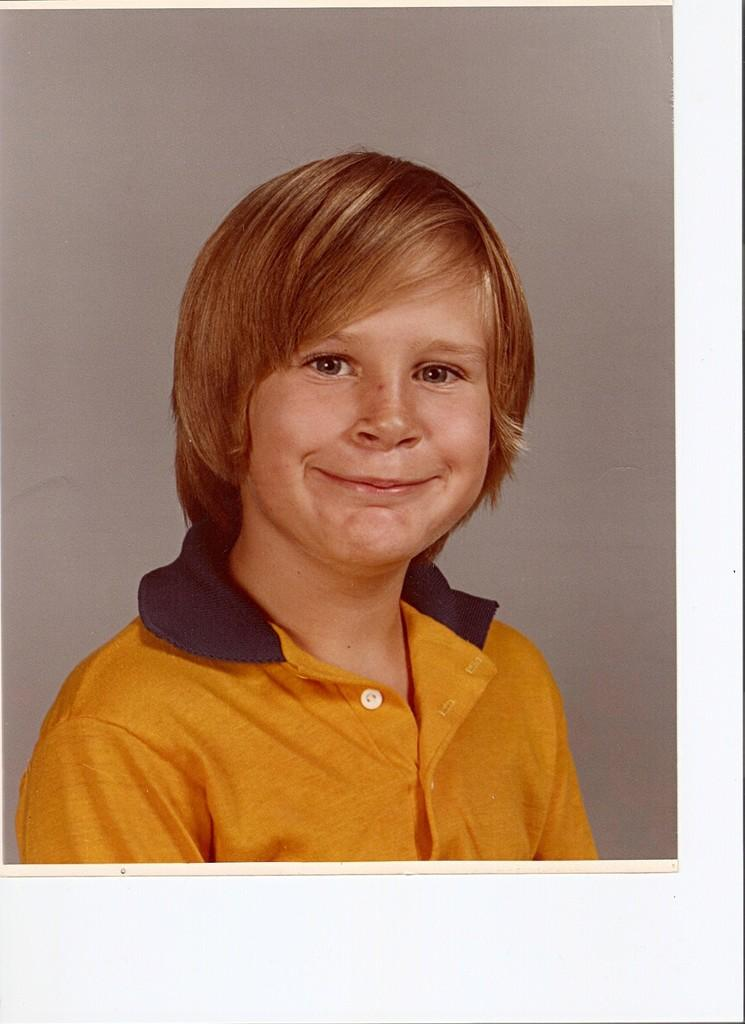What is the main subject of the image? There is a photo in the image. What can be seen in the photo? The photo contains a boy. What is the boy doing in the photo? The boy is standing in the photo. What is the boy's expression in the photo? The boy is smiling in the photo. What type of silk fabric is draped over the boy in the photo? There is no silk fabric present in the photo; the boy is simply standing and smiling. 